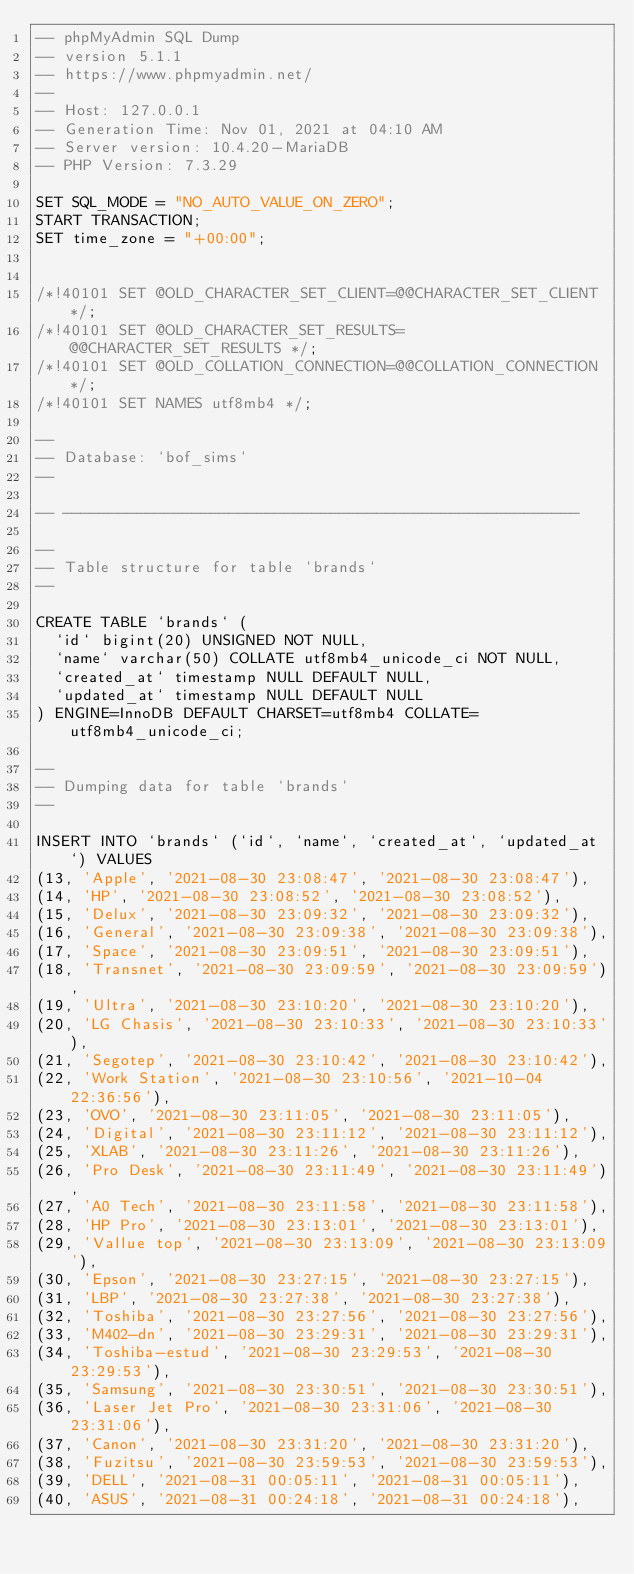<code> <loc_0><loc_0><loc_500><loc_500><_SQL_>-- phpMyAdmin SQL Dump
-- version 5.1.1
-- https://www.phpmyadmin.net/
--
-- Host: 127.0.0.1
-- Generation Time: Nov 01, 2021 at 04:10 AM
-- Server version: 10.4.20-MariaDB
-- PHP Version: 7.3.29

SET SQL_MODE = "NO_AUTO_VALUE_ON_ZERO";
START TRANSACTION;
SET time_zone = "+00:00";


/*!40101 SET @OLD_CHARACTER_SET_CLIENT=@@CHARACTER_SET_CLIENT */;
/*!40101 SET @OLD_CHARACTER_SET_RESULTS=@@CHARACTER_SET_RESULTS */;
/*!40101 SET @OLD_COLLATION_CONNECTION=@@COLLATION_CONNECTION */;
/*!40101 SET NAMES utf8mb4 */;

--
-- Database: `bof_sims`
--

-- --------------------------------------------------------

--
-- Table structure for table `brands`
--

CREATE TABLE `brands` (
  `id` bigint(20) UNSIGNED NOT NULL,
  `name` varchar(50) COLLATE utf8mb4_unicode_ci NOT NULL,
  `created_at` timestamp NULL DEFAULT NULL,
  `updated_at` timestamp NULL DEFAULT NULL
) ENGINE=InnoDB DEFAULT CHARSET=utf8mb4 COLLATE=utf8mb4_unicode_ci;

--
-- Dumping data for table `brands`
--

INSERT INTO `brands` (`id`, `name`, `created_at`, `updated_at`) VALUES
(13, 'Apple', '2021-08-30 23:08:47', '2021-08-30 23:08:47'),
(14, 'HP', '2021-08-30 23:08:52', '2021-08-30 23:08:52'),
(15, 'Delux', '2021-08-30 23:09:32', '2021-08-30 23:09:32'),
(16, 'General', '2021-08-30 23:09:38', '2021-08-30 23:09:38'),
(17, 'Space', '2021-08-30 23:09:51', '2021-08-30 23:09:51'),
(18, 'Transnet', '2021-08-30 23:09:59', '2021-08-30 23:09:59'),
(19, 'Ultra', '2021-08-30 23:10:20', '2021-08-30 23:10:20'),
(20, 'LG Chasis', '2021-08-30 23:10:33', '2021-08-30 23:10:33'),
(21, 'Segotep', '2021-08-30 23:10:42', '2021-08-30 23:10:42'),
(22, 'Work Station', '2021-08-30 23:10:56', '2021-10-04 22:36:56'),
(23, 'OVO', '2021-08-30 23:11:05', '2021-08-30 23:11:05'),
(24, 'Digital', '2021-08-30 23:11:12', '2021-08-30 23:11:12'),
(25, 'XLAB', '2021-08-30 23:11:26', '2021-08-30 23:11:26'),
(26, 'Pro Desk', '2021-08-30 23:11:49', '2021-08-30 23:11:49'),
(27, 'A0 Tech', '2021-08-30 23:11:58', '2021-08-30 23:11:58'),
(28, 'HP Pro', '2021-08-30 23:13:01', '2021-08-30 23:13:01'),
(29, 'Vallue top', '2021-08-30 23:13:09', '2021-08-30 23:13:09'),
(30, 'Epson', '2021-08-30 23:27:15', '2021-08-30 23:27:15'),
(31, 'LBP', '2021-08-30 23:27:38', '2021-08-30 23:27:38'),
(32, 'Toshiba', '2021-08-30 23:27:56', '2021-08-30 23:27:56'),
(33, 'M402-dn', '2021-08-30 23:29:31', '2021-08-30 23:29:31'),
(34, 'Toshiba-estud', '2021-08-30 23:29:53', '2021-08-30 23:29:53'),
(35, 'Samsung', '2021-08-30 23:30:51', '2021-08-30 23:30:51'),
(36, 'Laser Jet Pro', '2021-08-30 23:31:06', '2021-08-30 23:31:06'),
(37, 'Canon', '2021-08-30 23:31:20', '2021-08-30 23:31:20'),
(38, 'Fuzitsu', '2021-08-30 23:59:53', '2021-08-30 23:59:53'),
(39, 'DELL', '2021-08-31 00:05:11', '2021-08-31 00:05:11'),
(40, 'ASUS', '2021-08-31 00:24:18', '2021-08-31 00:24:18'),</code> 